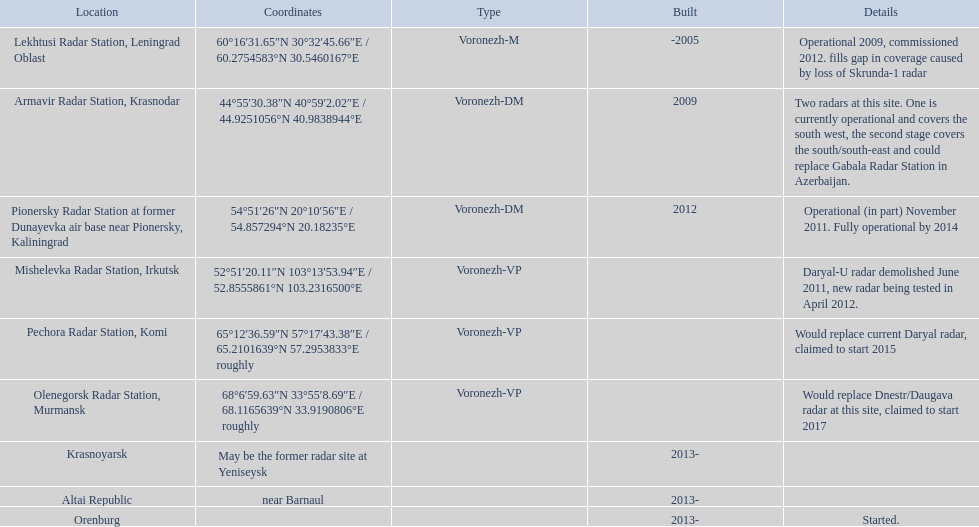What are the geographical positions of the radars? Lekhtusi Radar Station, Leningrad Oblast, Armavir Radar Station, Krasnodar, Pionersky Radar Station at former Dunayevka air base near Pionersky, Kaliningrad, Mishelevka Radar Station, Irkutsk, Pechora Radar Station, Komi, Olenegorsk Radar Station, Murmansk, Krasnoyarsk, Altai Republic, Orenburg. Can you give specifics about each radar? Operational 2009, commissioned 2012. fills gap in coverage caused by loss of Skrunda-1 radar, Two radars at this site. One is currently operational and covers the south west, the second stage covers the south/south-east and could replace Gabala Radar Station in Azerbaijan., Operational (in part) November 2011. Fully operational by 2014, Daryal-U radar demolished June 2011, new radar being tested in April 2012., Would replace current Daryal radar, claimed to start 2015, Would replace Dnestr/Daugava radar at this site, claimed to start 2017, , , Started. Which radar had its commencement set for 2015? Pechora Radar Station, Komi. 